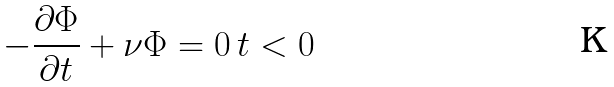Convert formula to latex. <formula><loc_0><loc_0><loc_500><loc_500>- \frac { \partial \Phi } { \partial t } + \nu \Phi = 0 \, t < 0</formula> 